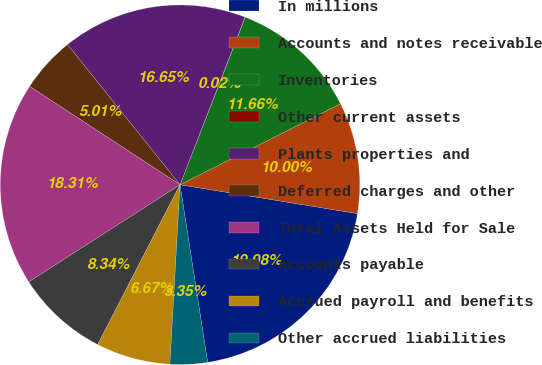Convert chart to OTSL. <chart><loc_0><loc_0><loc_500><loc_500><pie_chart><fcel>In millions<fcel>Accounts and notes receivable<fcel>Inventories<fcel>Other current assets<fcel>Plants properties and<fcel>Deferred charges and other<fcel>Total Assets Held for Sale<fcel>Accounts payable<fcel>Accrued payroll and benefits<fcel>Other accrued liabilities<nl><fcel>19.98%<fcel>10.0%<fcel>11.66%<fcel>0.02%<fcel>16.65%<fcel>5.01%<fcel>18.31%<fcel>8.34%<fcel>6.67%<fcel>3.35%<nl></chart> 